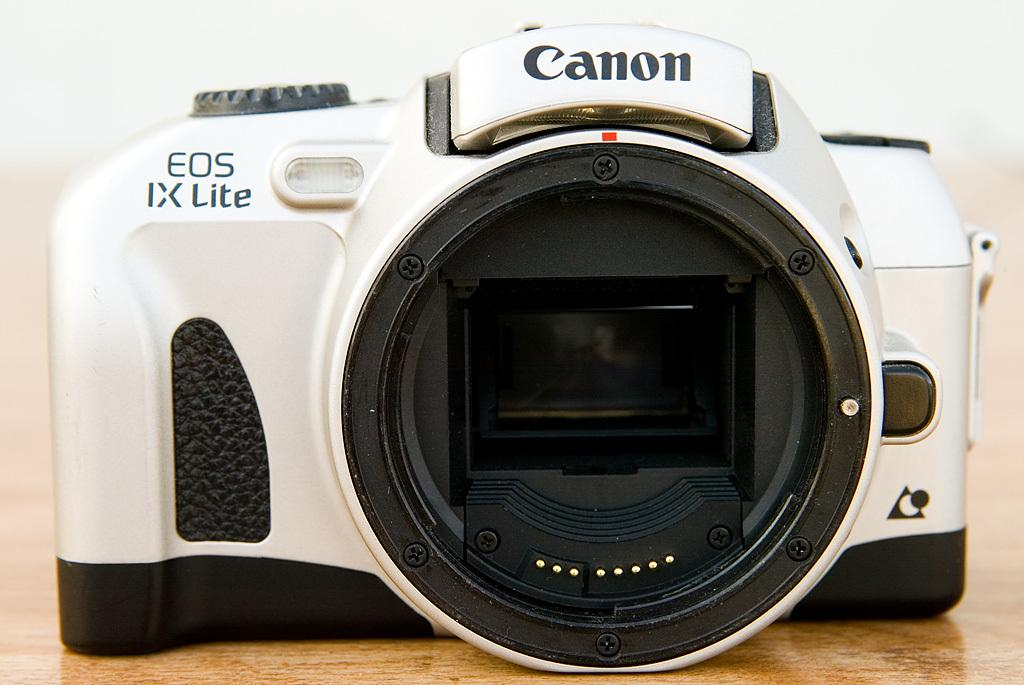<image>
Relay a brief, clear account of the picture shown. A white camera has a Canon logo on it. 